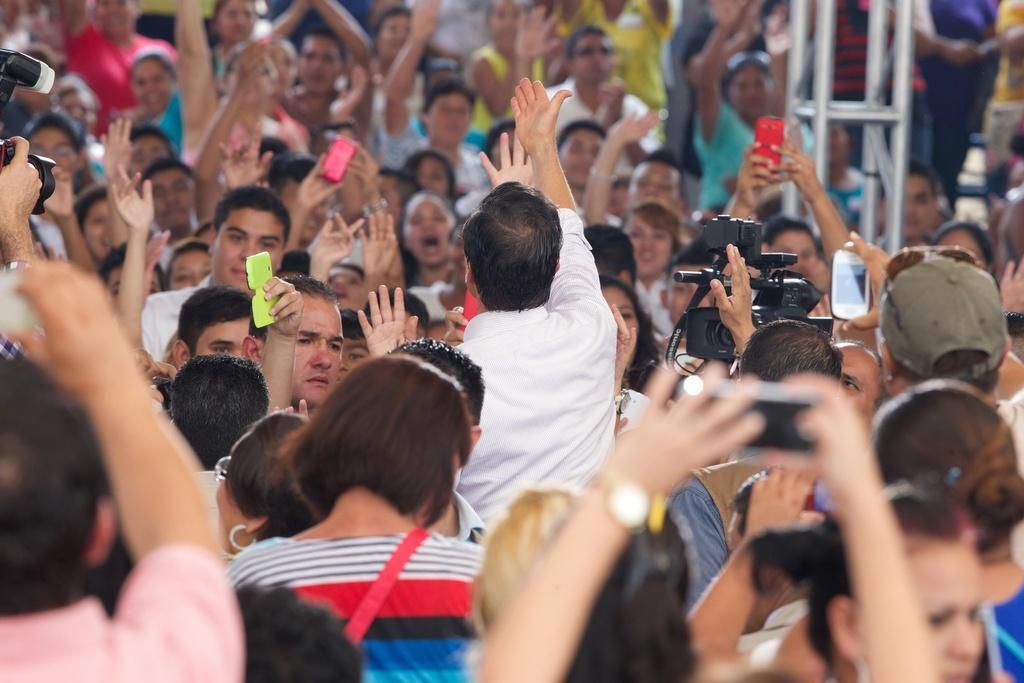What is the main subject of the image? The main subject of the image is a group of people. What are some of the people in the group doing? Some people in the group are raising their hands, and some are holding cameras. What type of stone can be seen in the image? There is no stone present in the image; it features a group of people with some raising their hands and others holding cameras. 